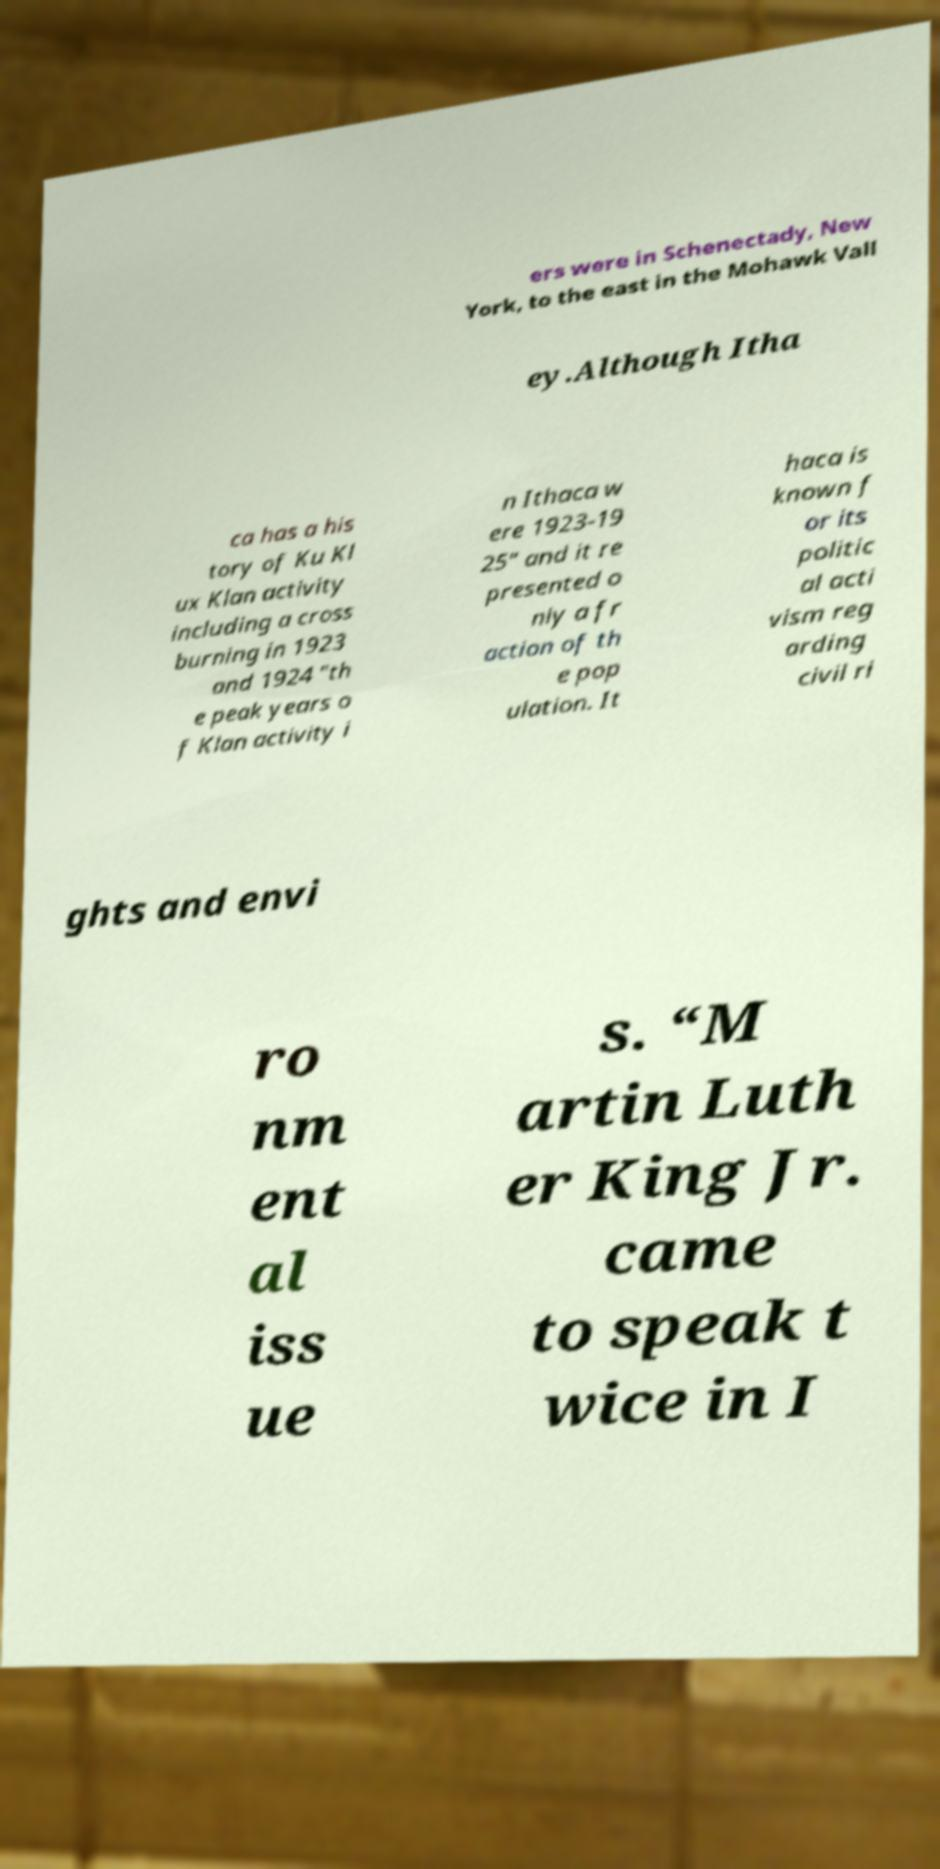For documentation purposes, I need the text within this image transcribed. Could you provide that? ers were in Schenectady, New York, to the east in the Mohawk Vall ey.Although Itha ca has a his tory of Ku Kl ux Klan activity including a cross burning in 1923 and 1924 "th e peak years o f Klan activity i n Ithaca w ere 1923-19 25" and it re presented o nly a fr action of th e pop ulation. It haca is known f or its politic al acti vism reg arding civil ri ghts and envi ro nm ent al iss ue s. “M artin Luth er King Jr. came to speak t wice in I 